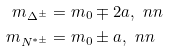Convert formula to latex. <formula><loc_0><loc_0><loc_500><loc_500>m _ { \Delta ^ { \pm } } & = m _ { 0 } \mp 2 a , \ n n \\ m _ { N ^ { * \pm } } & = m _ { 0 } \pm a , \ n n</formula> 